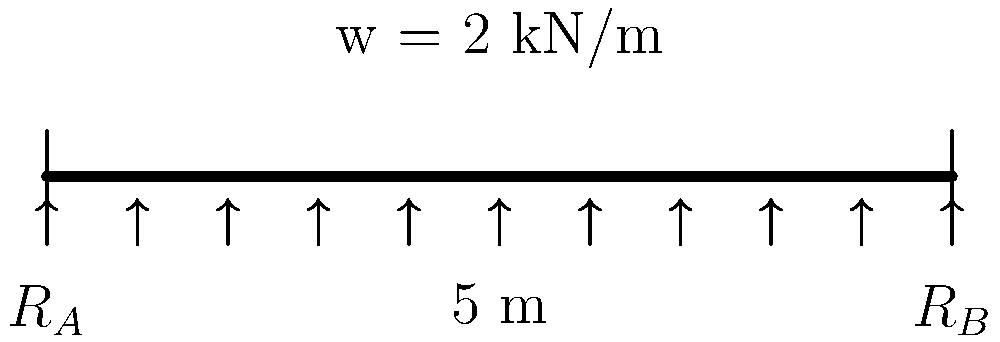Imagine you're hanging a heavy curtain rod across your living room window. The rod is like a beam supported at both ends, similar to the picture. If the curtain and rod together weigh 2 kN per meter (kind of like 2 big bags of flour per meter) and the window is 5 meters wide, how much weight does each end of the rod need to hold up? Let's break this down step-by-step:

1. First, we need to understand what we're looking at:
   - We have a beam (like our curtain rod) that's 5 meters long.
   - It has a distributed weight of 2 kN per meter (our curtain and rod).
   - It's supported at both ends (where we attach it to the wall).

2. To find how much weight each end holds, we need to calculate the total weight and then divide it equally (because the weight is evenly distributed).

3. Calculate the total weight:
   - Weight per meter = 2 kN/m
   - Length = 5 m
   - Total weight = 2 kN/m × 5 m = 10 kN

4. Since the weight is evenly distributed and the beam is supported at both ends, each end will bear half of the total weight.

5. Calculate the weight each end supports:
   - Weight per end = Total weight ÷ 2
   - Weight per end = 10 kN ÷ 2 = 5 kN

So, each end of the rod needs to hold up 5 kN, which is like holding about 5 big bags of flour.
Answer: 5 kN 